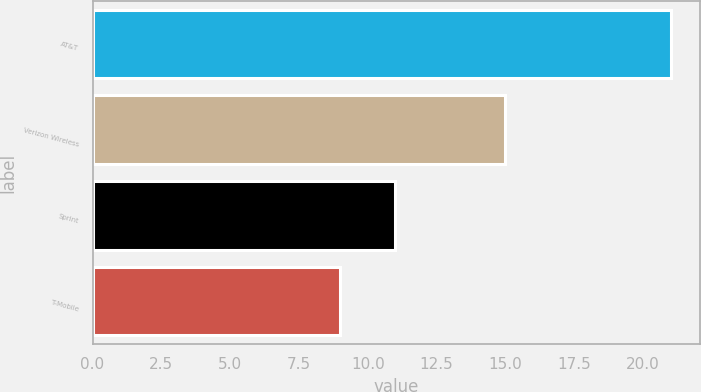Convert chart to OTSL. <chart><loc_0><loc_0><loc_500><loc_500><bar_chart><fcel>AT&T<fcel>Verizon Wireless<fcel>Sprint<fcel>T-Mobile<nl><fcel>21<fcel>15<fcel>11<fcel>9<nl></chart> 